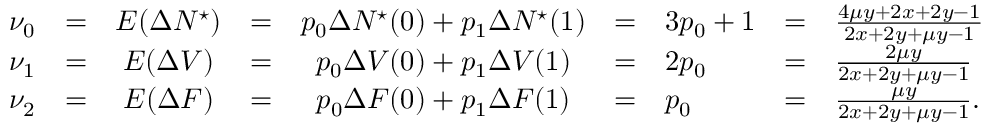Convert formula to latex. <formula><loc_0><loc_0><loc_500><loc_500>\begin{array} { r c c c c c l c l } { \nu _ { 0 } } & { = } & { E ( \Delta N ^ { ^ { * } } ) } & { = } & { p _ { 0 } \Delta N ^ { ^ { * } } ( 0 ) + p _ { 1 } \Delta N ^ { ^ { * } } ( 1 ) } & { = } & { 3 p _ { 0 } + 1 } & { = } & { \frac { 4 \mu y + 2 x + 2 y - 1 } { 2 x + 2 y + \mu y - 1 } } \\ { \nu _ { 1 } } & { = } & { E ( \Delta V ) } & { = } & { p _ { 0 } \Delta V ( 0 ) + p _ { 1 } \Delta V ( 1 ) } & { = } & { 2 p _ { 0 } } & { = } & { \frac { 2 \mu y } { 2 x + 2 y + \mu y - 1 } } \\ { \nu _ { 2 } } & { = } & { E ( \Delta F ) } & { = } & { p _ { 0 } \Delta F ( 0 ) + p _ { 1 } \Delta F ( 1 ) } & { = } & { p _ { 0 } } & { = } & { \frac { \mu y } { 2 x + 2 y + \mu y - 1 } . } \end{array}</formula> 